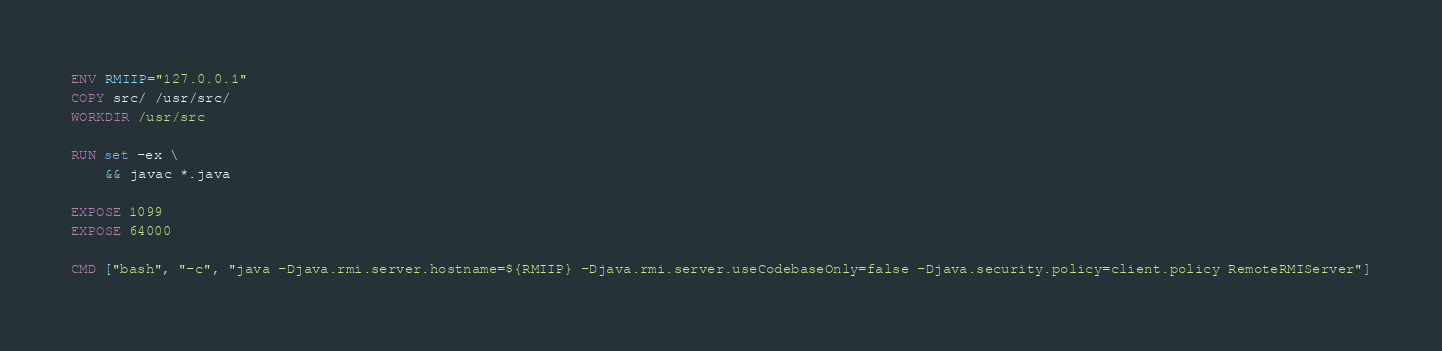<code> <loc_0><loc_0><loc_500><loc_500><_Dockerfile_>ENV RMIIP="127.0.0.1"
COPY src/ /usr/src/
WORKDIR /usr/src

RUN set -ex \
    && javac *.java

EXPOSE 1099
EXPOSE 64000

CMD ["bash", "-c", "java -Djava.rmi.server.hostname=${RMIIP} -Djava.rmi.server.useCodebaseOnly=false -Djava.security.policy=client.policy RemoteRMIServer"]
</code> 